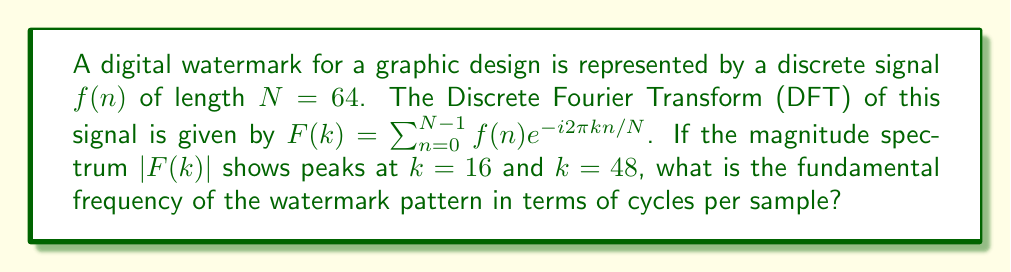What is the answer to this math problem? To solve this problem, we'll follow these steps:

1) The DFT of a signal of length $N$ gives us frequency components at $k = 0, 1, ..., N-1$.

2) The frequency resolution of the DFT is given by $\frac{f_s}{N}$, where $f_s$ is the sampling frequency. In digital signal processing, we often normalize $f_s$ to 1, giving us a frequency resolution of $\frac{1}{N}$.

3) The peaks in the magnitude spectrum occur at $k=16$ and $k=48$. These are symmetric around $N/2 = 32$, which indicates a real-valued signal.

4) The lower frequency peak at $k=16$ corresponds to the fundamental frequency. To convert this to cycles per sample, we use:

   $$f = \frac{k}{N} = \frac{16}{64} = \frac{1}{4}$$

5) This means the fundamental frequency is $\frac{1}{4}$ cycles per sample.

6) We can verify this by noting that the second peak at $k=48$ corresponds to $\frac{48}{64} = \frac{3}{4}$ cycles per sample, which is the third harmonic of $\frac{1}{4}$.

This frequency of $\frac{1}{4}$ cycles per sample means the watermark pattern repeats every 4 samples in the spatial domain, which could be a subtle but detectable pattern in a graphic design.
Answer: $\frac{1}{4}$ cycles per sample 